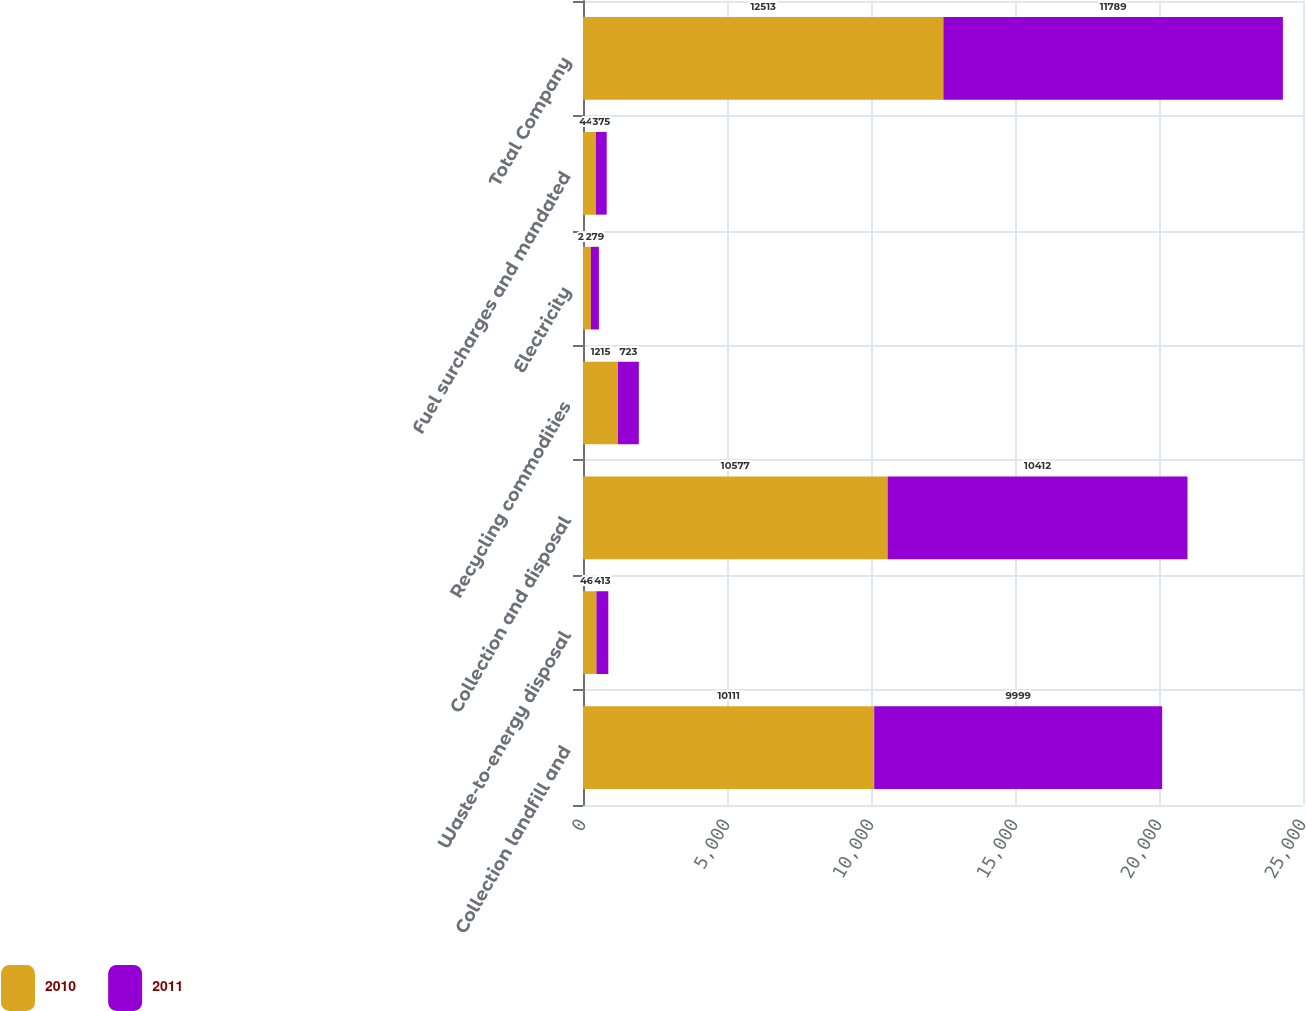Convert chart to OTSL. <chart><loc_0><loc_0><loc_500><loc_500><stacked_bar_chart><ecel><fcel>Collection landfill and<fcel>Waste-to-energy disposal<fcel>Collection and disposal<fcel>Recycling commodities<fcel>Electricity<fcel>Fuel surcharges and mandated<fcel>Total Company<nl><fcel>2010<fcel>10111<fcel>466<fcel>10577<fcel>1215<fcel>273<fcel>448<fcel>12513<nl><fcel>2011<fcel>9999<fcel>413<fcel>10412<fcel>723<fcel>279<fcel>375<fcel>11789<nl></chart> 